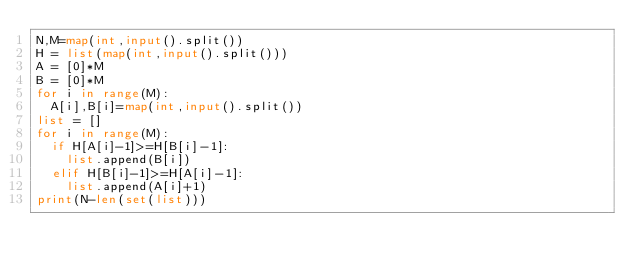Convert code to text. <code><loc_0><loc_0><loc_500><loc_500><_Python_>N,M=map(int,input().split())
H = list(map(int,input().split()))
A = [0]*M
B = [0]*M
for i in range(M):
  A[i],B[i]=map(int,input().split())
list = []
for i in range(M):
  if H[A[i]-1]>=H[B[i]-1]:
    list.append(B[i])
  elif H[B[i]-1]>=H[A[i]-1]:
    list.append(A[i]+1)
print(N-len(set(list)))</code> 